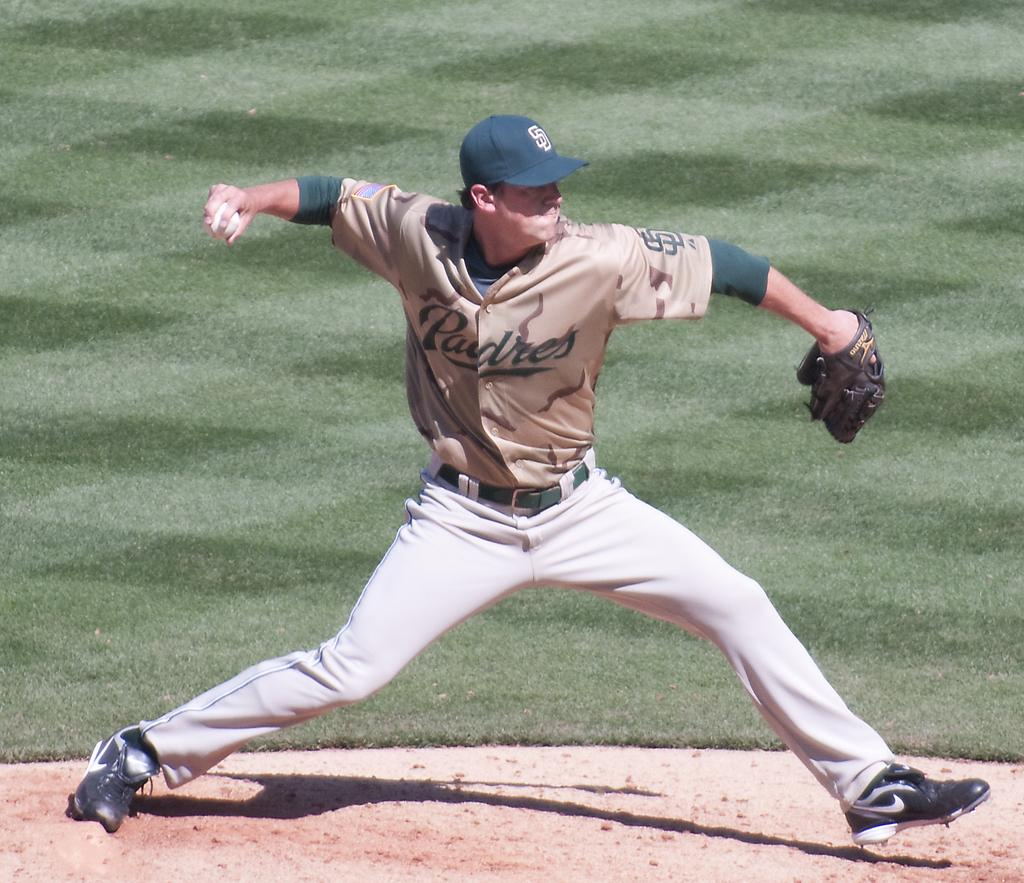<image>
Describe the image concisely. The Padres have green hats they are wearing in the game today, 